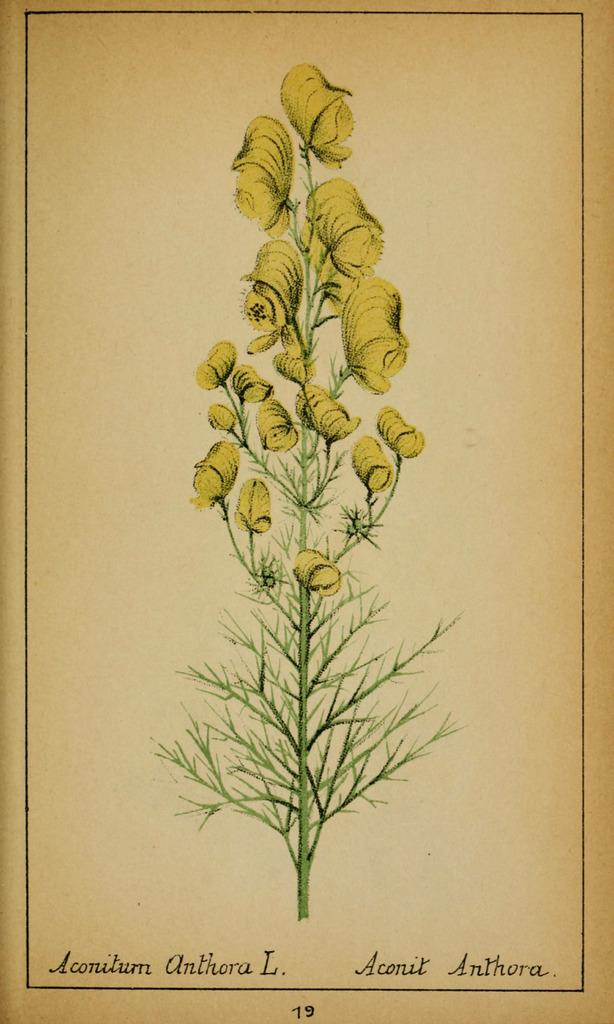What is depicted on the paper in the image? The paper has an image of a plant. Can you describe the plant in the image? The plant has stems, leaves, and flowers. What is written on the paper? There is text on the paper. What role does the manager play in the plant's growth in the image? There is no manager present in the image, and the plant's growth is not depicted. How many yards of grass are visible in the image? There is no yard or grass present in the image; it features a paper with an image of a plant. 